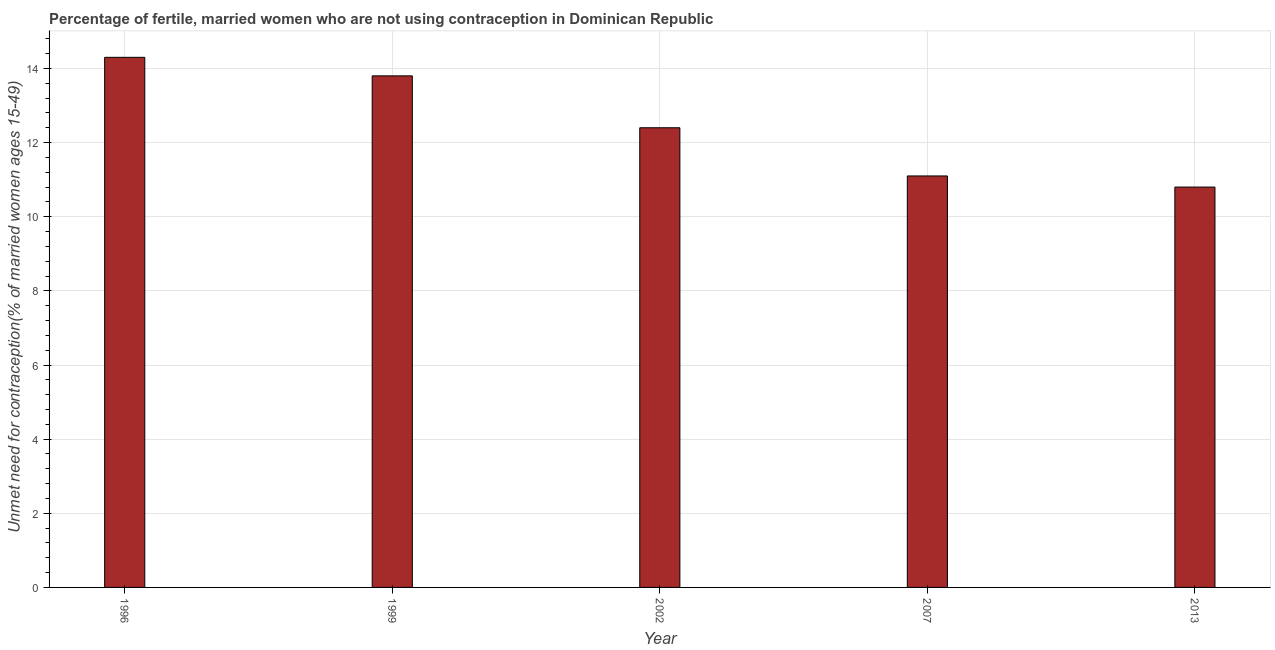Does the graph contain grids?
Give a very brief answer. Yes. What is the title of the graph?
Ensure brevity in your answer.  Percentage of fertile, married women who are not using contraception in Dominican Republic. What is the label or title of the X-axis?
Offer a terse response. Year. What is the label or title of the Y-axis?
Offer a terse response.  Unmet need for contraception(% of married women ages 15-49). Across all years, what is the maximum number of married women who are not using contraception?
Keep it short and to the point. 14.3. Across all years, what is the minimum number of married women who are not using contraception?
Your answer should be compact. 10.8. In which year was the number of married women who are not using contraception maximum?
Provide a short and direct response. 1996. In which year was the number of married women who are not using contraception minimum?
Provide a succinct answer. 2013. What is the sum of the number of married women who are not using contraception?
Your answer should be very brief. 62.4. What is the difference between the number of married women who are not using contraception in 1996 and 2007?
Ensure brevity in your answer.  3.2. What is the average number of married women who are not using contraception per year?
Your answer should be very brief. 12.48. What is the median number of married women who are not using contraception?
Provide a short and direct response. 12.4. In how many years, is the number of married women who are not using contraception greater than 12.8 %?
Your answer should be compact. 2. Do a majority of the years between 2002 and 1996 (inclusive) have number of married women who are not using contraception greater than 4.8 %?
Provide a succinct answer. Yes. What is the ratio of the number of married women who are not using contraception in 2002 to that in 2013?
Your response must be concise. 1.15. Is the number of married women who are not using contraception in 1996 less than that in 2013?
Make the answer very short. No. Is the sum of the number of married women who are not using contraception in 1996 and 2013 greater than the maximum number of married women who are not using contraception across all years?
Make the answer very short. Yes. In how many years, is the number of married women who are not using contraception greater than the average number of married women who are not using contraception taken over all years?
Provide a succinct answer. 2. Are all the bars in the graph horizontal?
Provide a succinct answer. No. What is the difference between two consecutive major ticks on the Y-axis?
Keep it short and to the point. 2. Are the values on the major ticks of Y-axis written in scientific E-notation?
Provide a succinct answer. No. What is the  Unmet need for contraception(% of married women ages 15-49) in 1996?
Offer a terse response. 14.3. What is the  Unmet need for contraception(% of married women ages 15-49) in 2013?
Your answer should be compact. 10.8. What is the difference between the  Unmet need for contraception(% of married women ages 15-49) in 1996 and 2007?
Make the answer very short. 3.2. What is the difference between the  Unmet need for contraception(% of married women ages 15-49) in 1996 and 2013?
Ensure brevity in your answer.  3.5. What is the difference between the  Unmet need for contraception(% of married women ages 15-49) in 1999 and 2013?
Your answer should be very brief. 3. What is the difference between the  Unmet need for contraception(% of married women ages 15-49) in 2002 and 2007?
Your response must be concise. 1.3. What is the difference between the  Unmet need for contraception(% of married women ages 15-49) in 2002 and 2013?
Your response must be concise. 1.6. What is the difference between the  Unmet need for contraception(% of married women ages 15-49) in 2007 and 2013?
Your answer should be compact. 0.3. What is the ratio of the  Unmet need for contraception(% of married women ages 15-49) in 1996 to that in 1999?
Give a very brief answer. 1.04. What is the ratio of the  Unmet need for contraception(% of married women ages 15-49) in 1996 to that in 2002?
Your answer should be very brief. 1.15. What is the ratio of the  Unmet need for contraception(% of married women ages 15-49) in 1996 to that in 2007?
Offer a very short reply. 1.29. What is the ratio of the  Unmet need for contraception(% of married women ages 15-49) in 1996 to that in 2013?
Ensure brevity in your answer.  1.32. What is the ratio of the  Unmet need for contraception(% of married women ages 15-49) in 1999 to that in 2002?
Keep it short and to the point. 1.11. What is the ratio of the  Unmet need for contraception(% of married women ages 15-49) in 1999 to that in 2007?
Make the answer very short. 1.24. What is the ratio of the  Unmet need for contraception(% of married women ages 15-49) in 1999 to that in 2013?
Your response must be concise. 1.28. What is the ratio of the  Unmet need for contraception(% of married women ages 15-49) in 2002 to that in 2007?
Offer a very short reply. 1.12. What is the ratio of the  Unmet need for contraception(% of married women ages 15-49) in 2002 to that in 2013?
Keep it short and to the point. 1.15. What is the ratio of the  Unmet need for contraception(% of married women ages 15-49) in 2007 to that in 2013?
Your response must be concise. 1.03. 